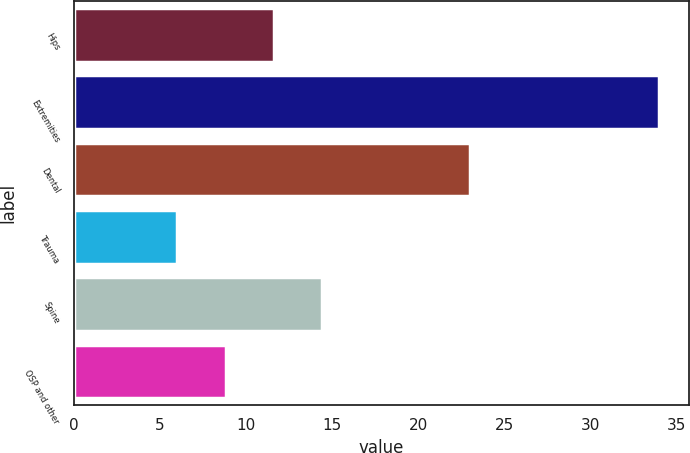Convert chart. <chart><loc_0><loc_0><loc_500><loc_500><bar_chart><fcel>Hips<fcel>Extremities<fcel>Dental<fcel>Trauma<fcel>Spine<fcel>OSP and other<nl><fcel>11.6<fcel>34<fcel>23<fcel>6<fcel>14.4<fcel>8.8<nl></chart> 